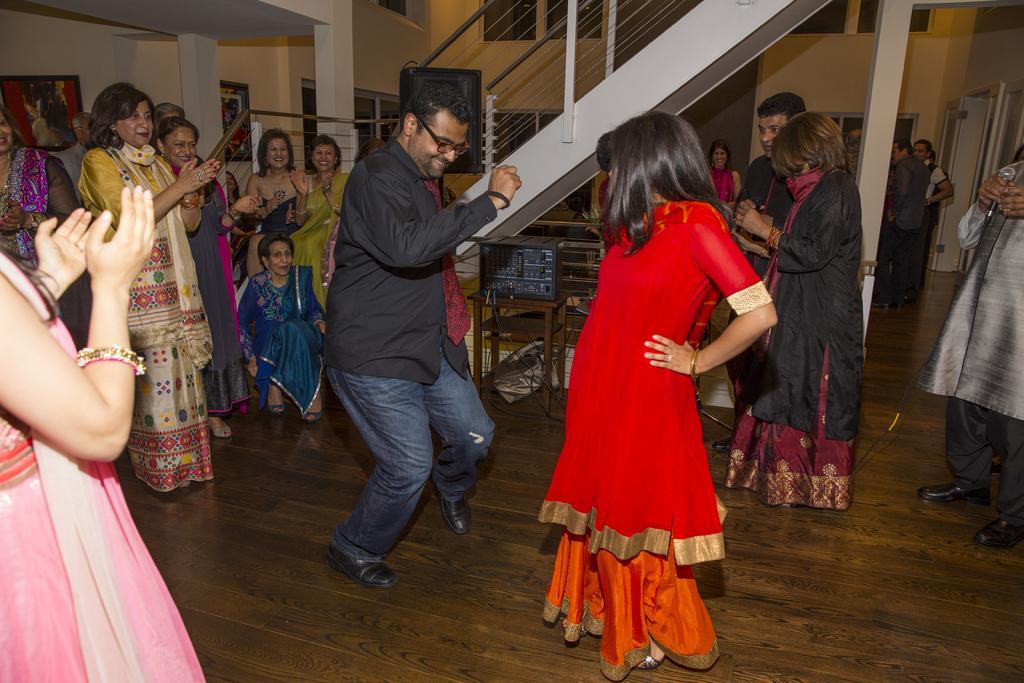Could you give a brief overview of what you see in this image? This image consists of some persons in the middle. They are dancing. There are stairs at the top. There is a door on the right side. 